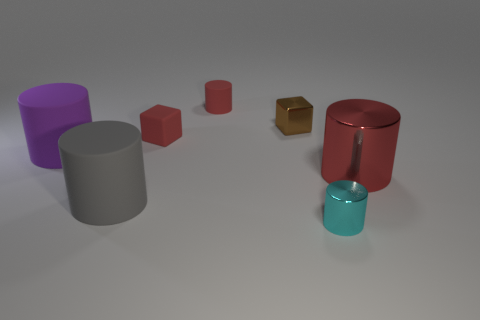What is the color of the tiny thing that is left of the small red cylinder?
Ensure brevity in your answer.  Red. What number of green things are either small metal blocks or rubber blocks?
Offer a terse response. 0. The large metal thing is what color?
Ensure brevity in your answer.  Red. Is the number of big metal cylinders that are to the left of the large red cylinder less than the number of small metallic things that are behind the gray matte object?
Keep it short and to the point. Yes. What shape is the thing that is left of the small rubber block and in front of the red metal cylinder?
Your answer should be very brief. Cylinder. What number of small blue objects have the same shape as the gray rubber thing?
Offer a very short reply. 0. The red cube that is the same material as the gray object is what size?
Give a very brief answer. Small. What number of objects are the same size as the red matte cube?
Make the answer very short. 3. There is a rubber cylinder that is the same color as the big shiny cylinder; what is its size?
Keep it short and to the point. Small. There is a big cylinder that is on the right side of the tiny block that is to the right of the red block; what color is it?
Offer a very short reply. Red. 